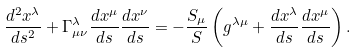Convert formula to latex. <formula><loc_0><loc_0><loc_500><loc_500>\frac { d ^ { 2 } x ^ { \lambda } } { d s ^ { 2 } } + \Gamma ^ { \lambda } _ { \mu \nu } \frac { d x ^ { \mu } } { d s } \frac { d x ^ { \nu } } { d s } = - \frac { S _ { \mu } } { S } \left ( g ^ { \lambda \mu } + \frac { d x ^ { \lambda } } { d s } \frac { d x ^ { \mu } } { d s } \right ) .</formula> 